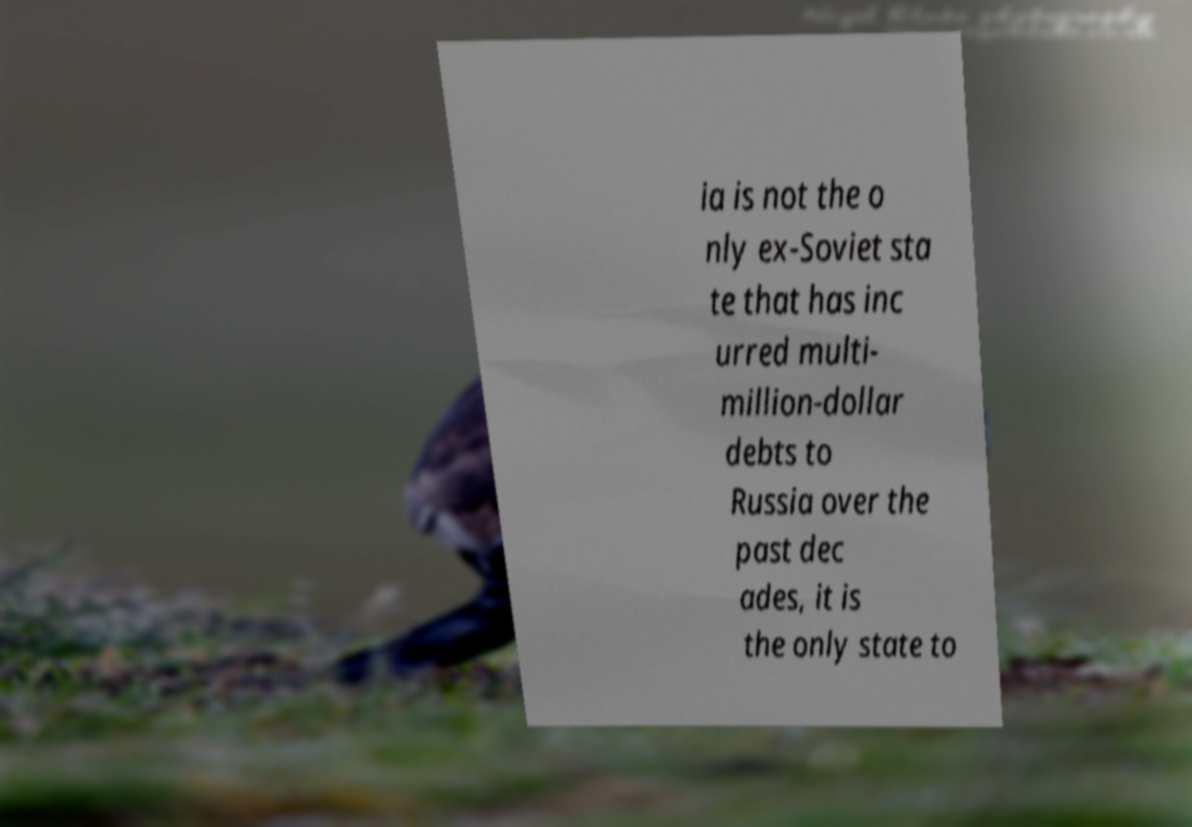Could you assist in decoding the text presented in this image and type it out clearly? ia is not the o nly ex-Soviet sta te that has inc urred multi- million-dollar debts to Russia over the past dec ades, it is the only state to 